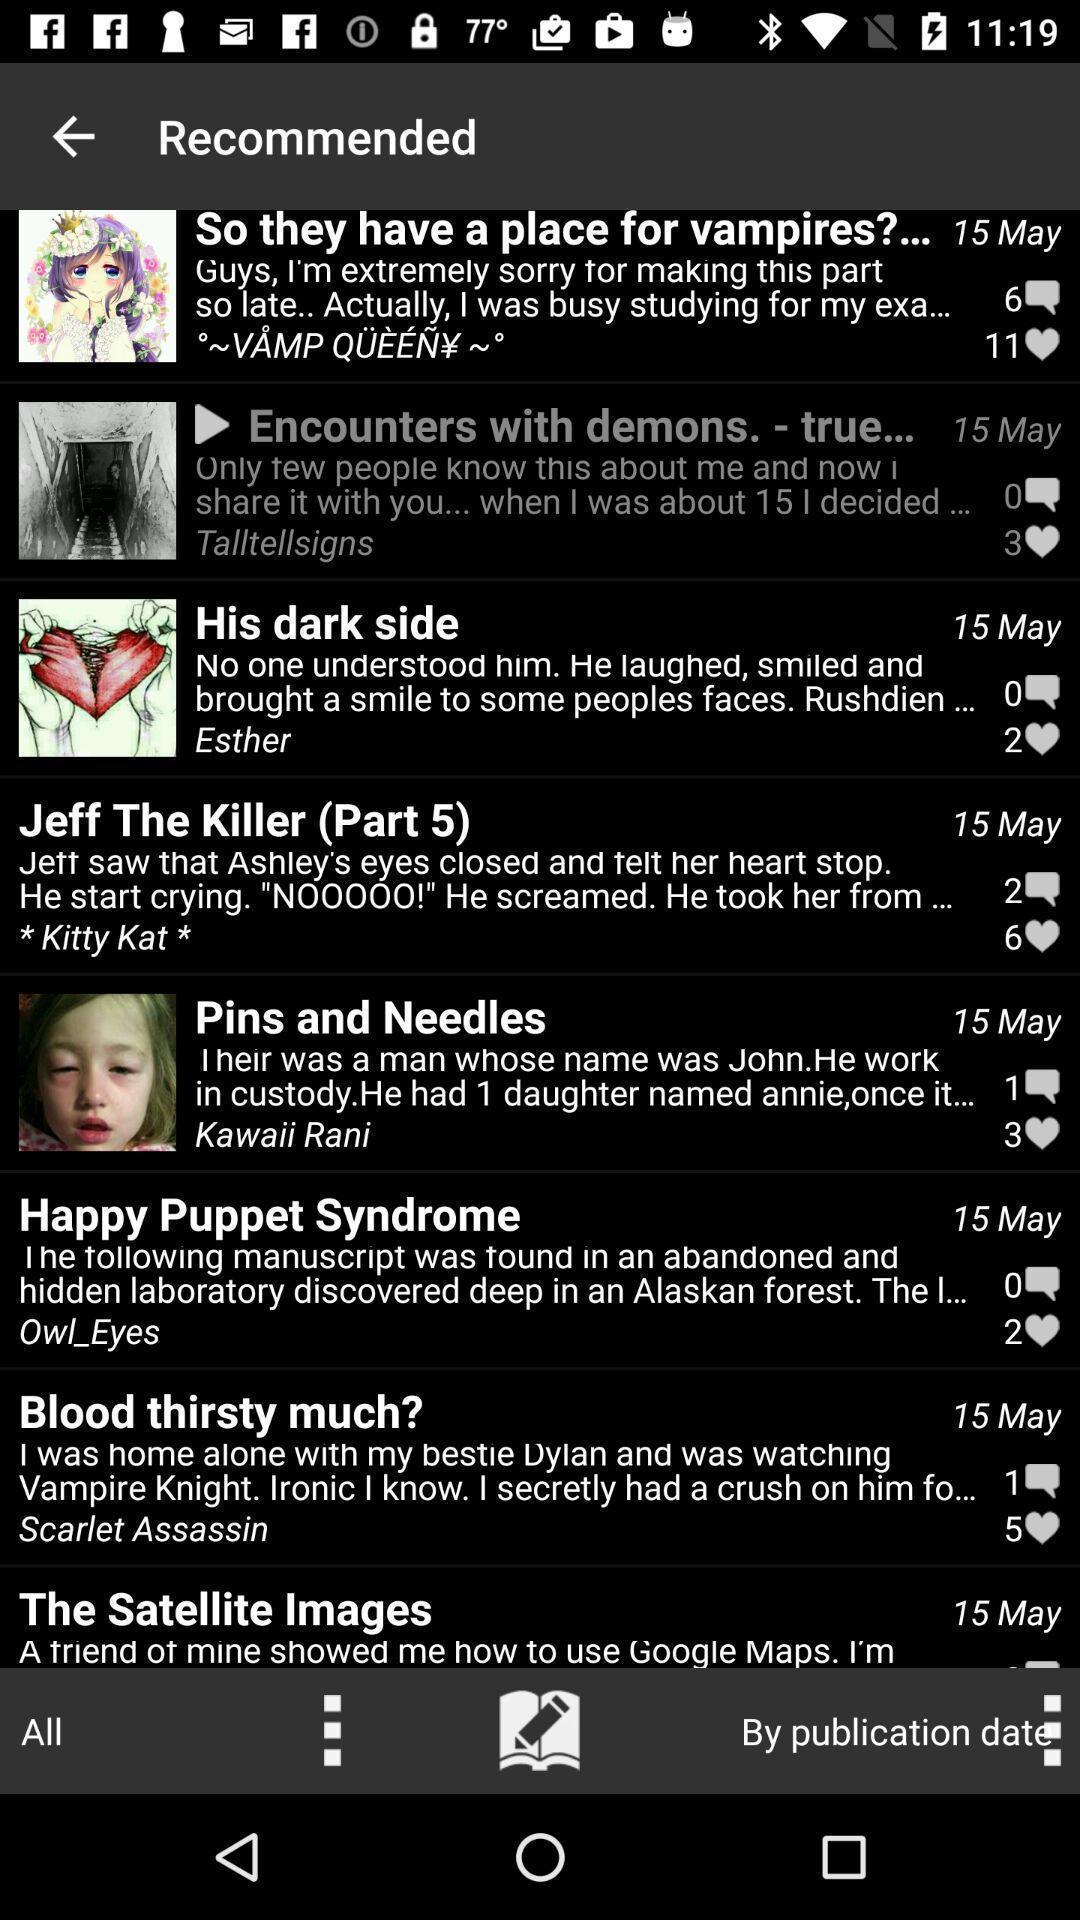Describe the key features of this screenshot. Page is showing recommended. 